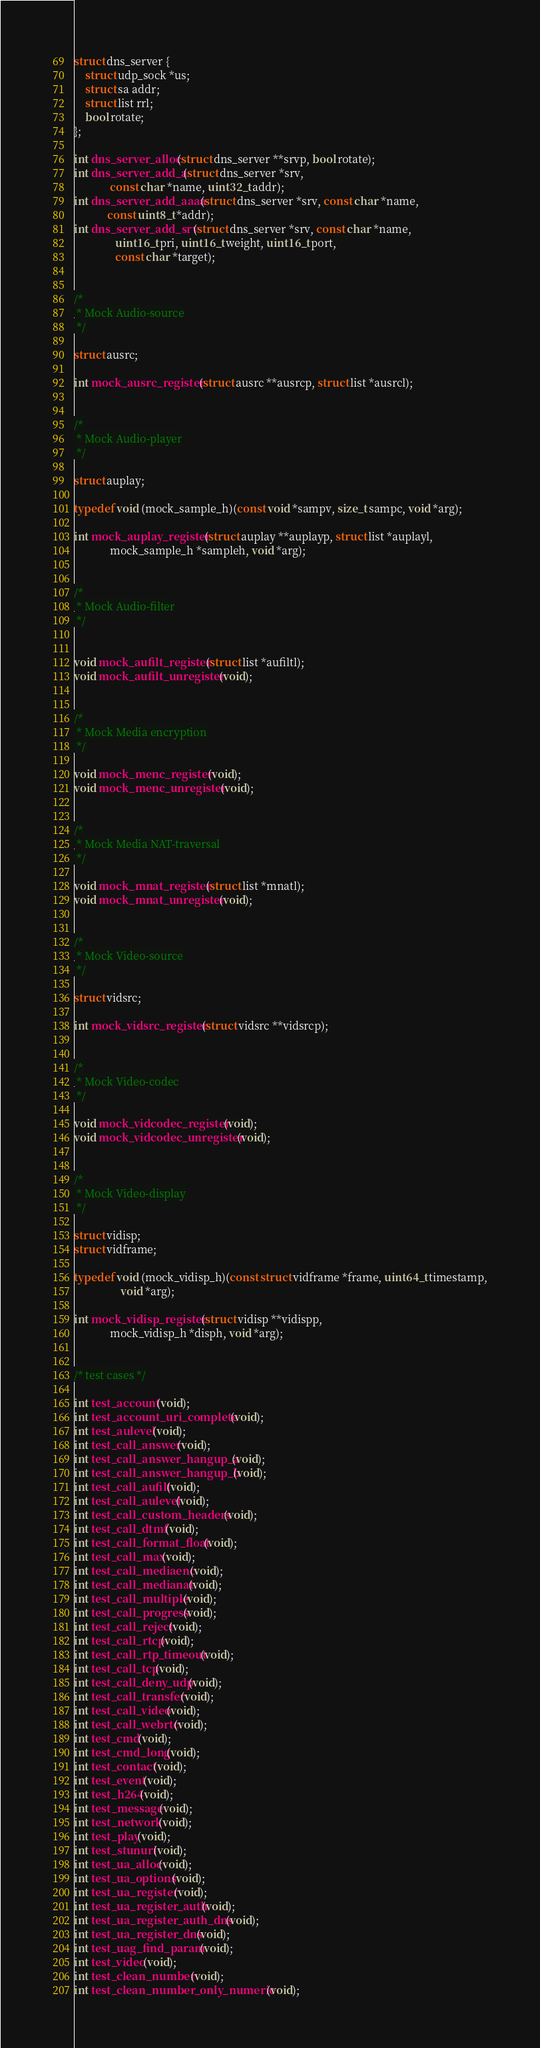<code> <loc_0><loc_0><loc_500><loc_500><_C_>struct dns_server {
	struct udp_sock *us;
	struct sa addr;
	struct list rrl;
	bool rotate;
};

int dns_server_alloc(struct dns_server **srvp, bool rotate);
int dns_server_add_a(struct dns_server *srv,
		     const char *name, uint32_t addr);
int dns_server_add_aaaa(struct dns_server *srv, const char *name,
			const uint8_t *addr);
int dns_server_add_srv(struct dns_server *srv, const char *name,
		       uint16_t pri, uint16_t weight, uint16_t port,
		       const char *target);


/*
 * Mock Audio-source
 */

struct ausrc;

int mock_ausrc_register(struct ausrc **ausrcp, struct list *ausrcl);


/*
 * Mock Audio-player
 */

struct auplay;

typedef void (mock_sample_h)(const void *sampv, size_t sampc, void *arg);

int mock_auplay_register(struct auplay **auplayp, struct list *auplayl,
			 mock_sample_h *sampleh, void *arg);


/*
 * Mock Audio-filter
 */


void mock_aufilt_register(struct list *aufiltl);
void mock_aufilt_unregister(void);


/*
 * Mock Media encryption
 */

void mock_menc_register(void);
void mock_menc_unregister(void);


/*
 * Mock Media NAT-traversal
 */

void mock_mnat_register(struct list *mnatl);
void mock_mnat_unregister(void);


/*
 * Mock Video-source
 */

struct vidsrc;

int mock_vidsrc_register(struct vidsrc **vidsrcp);


/*
 * Mock Video-codec
 */

void mock_vidcodec_register(void);
void mock_vidcodec_unregister(void);


/*
 * Mock Video-display
 */

struct vidisp;
struct vidframe;

typedef void (mock_vidisp_h)(const struct vidframe *frame, uint64_t timestamp,
			     void *arg);

int mock_vidisp_register(struct vidisp **vidispp,
			 mock_vidisp_h *disph, void *arg);


/* test cases */

int test_account(void);
int test_account_uri_complete(void);
int test_aulevel(void);
int test_call_answer(void);
int test_call_answer_hangup_a(void);
int test_call_answer_hangup_b(void);
int test_call_aufilt(void);
int test_call_aulevel(void);
int test_call_custom_headers(void);
int test_call_dtmf(void);
int test_call_format_float(void);
int test_call_max(void);
int test_call_mediaenc(void);
int test_call_medianat(void);
int test_call_multiple(void);
int test_call_progress(void);
int test_call_reject(void);
int test_call_rtcp(void);
int test_call_rtp_timeout(void);
int test_call_tcp(void);
int test_call_deny_udp(void);
int test_call_transfer(void);
int test_call_video(void);
int test_call_webrtc(void);
int test_cmd(void);
int test_cmd_long(void);
int test_contact(void);
int test_event(void);
int test_h264(void);
int test_message(void);
int test_network(void);
int test_play(void);
int test_stunuri(void);
int test_ua_alloc(void);
int test_ua_options(void);
int test_ua_register(void);
int test_ua_register_auth(void);
int test_ua_register_auth_dns(void);
int test_ua_register_dns(void);
int test_uag_find_param(void);
int test_video(void);
int test_clean_number(void);
int test_clean_number_only_numeric(void);
</code> 